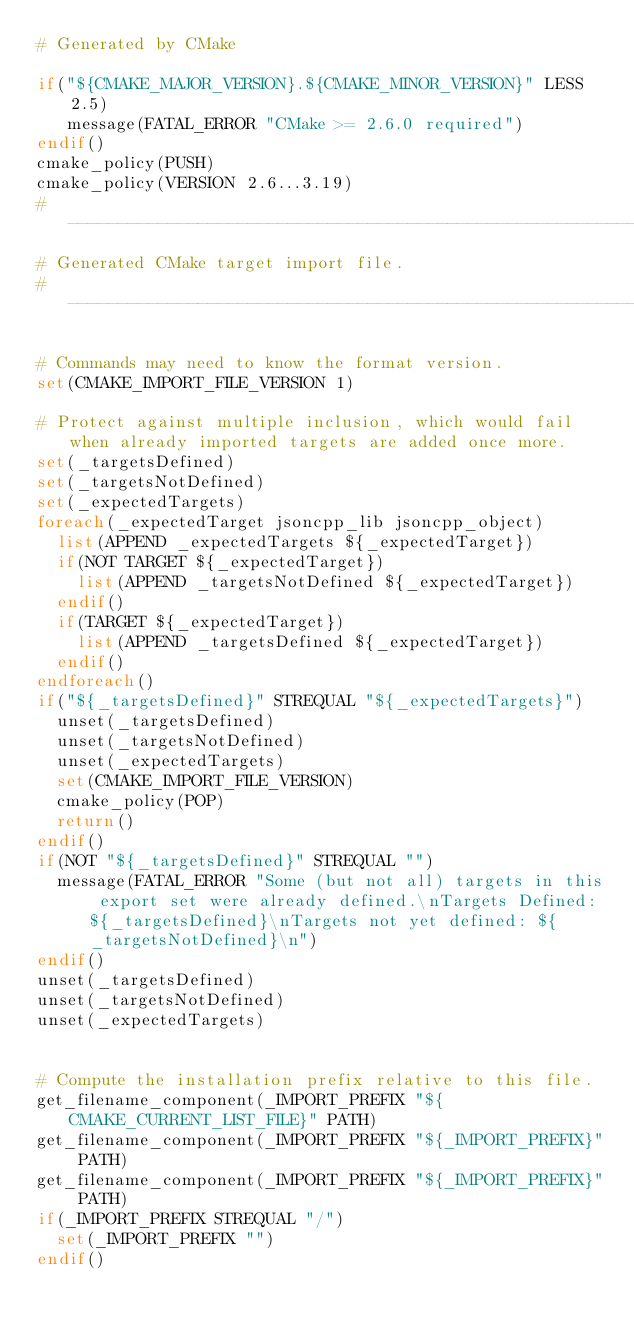Convert code to text. <code><loc_0><loc_0><loc_500><loc_500><_CMake_># Generated by CMake

if("${CMAKE_MAJOR_VERSION}.${CMAKE_MINOR_VERSION}" LESS 2.5)
   message(FATAL_ERROR "CMake >= 2.6.0 required")
endif()
cmake_policy(PUSH)
cmake_policy(VERSION 2.6...3.19)
#----------------------------------------------------------------
# Generated CMake target import file.
#----------------------------------------------------------------

# Commands may need to know the format version.
set(CMAKE_IMPORT_FILE_VERSION 1)

# Protect against multiple inclusion, which would fail when already imported targets are added once more.
set(_targetsDefined)
set(_targetsNotDefined)
set(_expectedTargets)
foreach(_expectedTarget jsoncpp_lib jsoncpp_object)
  list(APPEND _expectedTargets ${_expectedTarget})
  if(NOT TARGET ${_expectedTarget})
    list(APPEND _targetsNotDefined ${_expectedTarget})
  endif()
  if(TARGET ${_expectedTarget})
    list(APPEND _targetsDefined ${_expectedTarget})
  endif()
endforeach()
if("${_targetsDefined}" STREQUAL "${_expectedTargets}")
  unset(_targetsDefined)
  unset(_targetsNotDefined)
  unset(_expectedTargets)
  set(CMAKE_IMPORT_FILE_VERSION)
  cmake_policy(POP)
  return()
endif()
if(NOT "${_targetsDefined}" STREQUAL "")
  message(FATAL_ERROR "Some (but not all) targets in this export set were already defined.\nTargets Defined: ${_targetsDefined}\nTargets not yet defined: ${_targetsNotDefined}\n")
endif()
unset(_targetsDefined)
unset(_targetsNotDefined)
unset(_expectedTargets)


# Compute the installation prefix relative to this file.
get_filename_component(_IMPORT_PREFIX "${CMAKE_CURRENT_LIST_FILE}" PATH)
get_filename_component(_IMPORT_PREFIX "${_IMPORT_PREFIX}" PATH)
get_filename_component(_IMPORT_PREFIX "${_IMPORT_PREFIX}" PATH)
if(_IMPORT_PREFIX STREQUAL "/")
  set(_IMPORT_PREFIX "")
endif()
</code> 